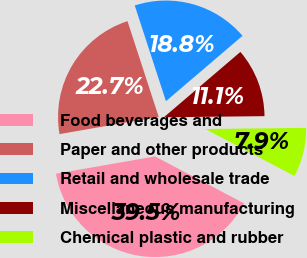Convert chart to OTSL. <chart><loc_0><loc_0><loc_500><loc_500><pie_chart><fcel>Food beverages and<fcel>Paper and other products<fcel>Retail and wholesale trade<fcel>Miscellaneous manufacturing<fcel>Chemical plastic and rubber<nl><fcel>39.53%<fcel>22.73%<fcel>18.77%<fcel>11.07%<fcel>7.91%<nl></chart> 